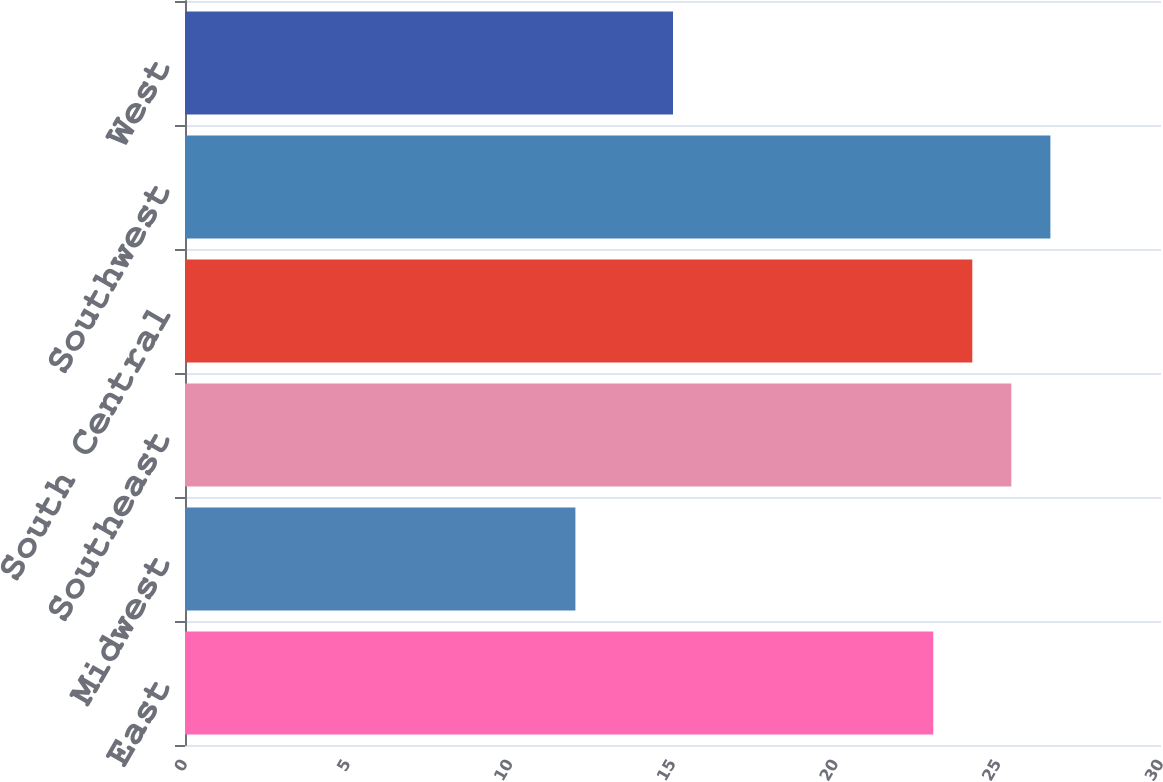Convert chart to OTSL. <chart><loc_0><loc_0><loc_500><loc_500><bar_chart><fcel>East<fcel>Midwest<fcel>Southeast<fcel>South Central<fcel>Southwest<fcel>West<nl><fcel>23<fcel>12<fcel>25.4<fcel>24.2<fcel>26.6<fcel>15<nl></chart> 